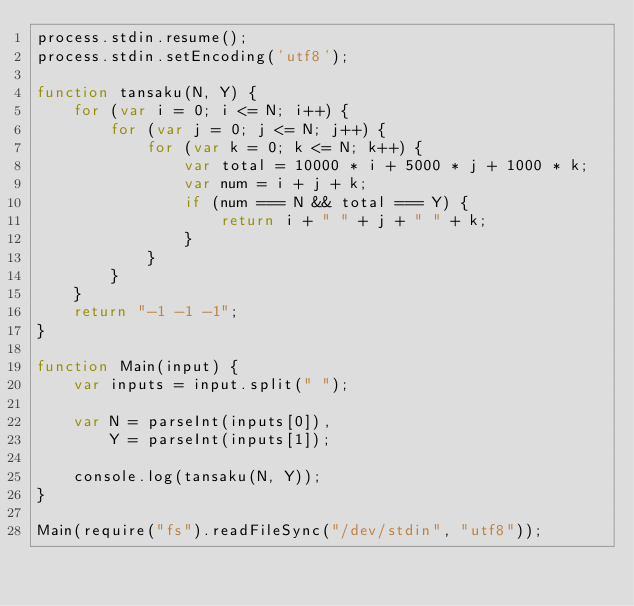<code> <loc_0><loc_0><loc_500><loc_500><_JavaScript_>process.stdin.resume();
process.stdin.setEncoding('utf8');

function tansaku(N, Y) {
    for (var i = 0; i <= N; i++) {
        for (var j = 0; j <= N; j++) {
            for (var k = 0; k <= N; k++) {
                var total = 10000 * i + 5000 * j + 1000 * k;
                var num = i + j + k;
                if (num === N && total === Y) {
                    return i + " " + j + " " + k;
                }
            }
        }
    }
    return "-1 -1 -1";
}

function Main(input) {
    var inputs = input.split(" ");
    
    var N = parseInt(inputs[0]),
        Y = parseInt(inputs[1]);

    console.log(tansaku(N, Y));
}

Main(require("fs").readFileSync("/dev/stdin", "utf8"));</code> 